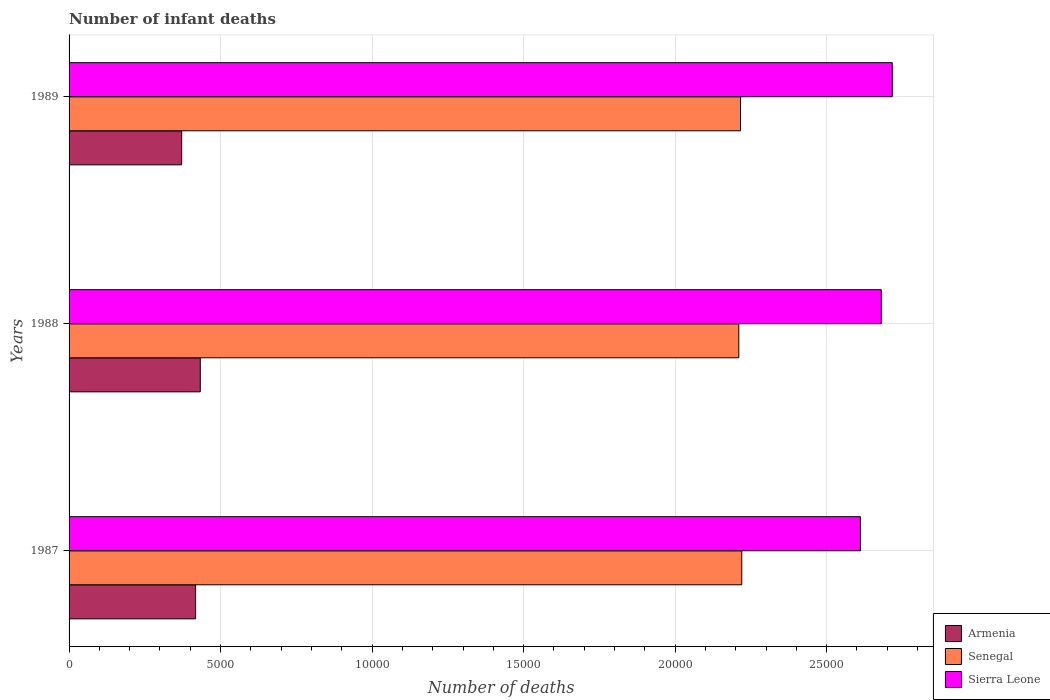How many groups of bars are there?
Your answer should be compact. 3. Are the number of bars per tick equal to the number of legend labels?
Offer a very short reply. Yes. What is the label of the 3rd group of bars from the top?
Provide a succinct answer. 1987. In how many cases, is the number of bars for a given year not equal to the number of legend labels?
Make the answer very short. 0. What is the number of infant deaths in Sierra Leone in 1987?
Ensure brevity in your answer.  2.61e+04. Across all years, what is the maximum number of infant deaths in Sierra Leone?
Provide a short and direct response. 2.72e+04. Across all years, what is the minimum number of infant deaths in Senegal?
Your response must be concise. 2.21e+04. What is the total number of infant deaths in Sierra Leone in the graph?
Your answer should be compact. 8.01e+04. What is the difference between the number of infant deaths in Sierra Leone in 1988 and that in 1989?
Keep it short and to the point. -363. What is the difference between the number of infant deaths in Senegal in 1987 and the number of infant deaths in Armenia in 1989?
Your answer should be very brief. 1.85e+04. What is the average number of infant deaths in Senegal per year?
Give a very brief answer. 2.22e+04. In the year 1989, what is the difference between the number of infant deaths in Sierra Leone and number of infant deaths in Armenia?
Your answer should be compact. 2.34e+04. In how many years, is the number of infant deaths in Sierra Leone greater than 15000 ?
Your answer should be compact. 3. What is the ratio of the number of infant deaths in Armenia in 1987 to that in 1989?
Ensure brevity in your answer.  1.12. Is the number of infant deaths in Sierra Leone in 1988 less than that in 1989?
Ensure brevity in your answer.  Yes. Is the difference between the number of infant deaths in Sierra Leone in 1987 and 1988 greater than the difference between the number of infant deaths in Armenia in 1987 and 1988?
Give a very brief answer. No. What is the difference between the highest and the second highest number of infant deaths in Armenia?
Your answer should be very brief. 155. What is the difference between the highest and the lowest number of infant deaths in Armenia?
Ensure brevity in your answer.  614. Is the sum of the number of infant deaths in Armenia in 1988 and 1989 greater than the maximum number of infant deaths in Senegal across all years?
Offer a terse response. No. What does the 3rd bar from the top in 1988 represents?
Your answer should be very brief. Armenia. What does the 2nd bar from the bottom in 1987 represents?
Provide a short and direct response. Senegal. Is it the case that in every year, the sum of the number of infant deaths in Sierra Leone and number of infant deaths in Senegal is greater than the number of infant deaths in Armenia?
Your answer should be very brief. Yes. How many years are there in the graph?
Provide a succinct answer. 3. Are the values on the major ticks of X-axis written in scientific E-notation?
Your answer should be compact. No. Where does the legend appear in the graph?
Ensure brevity in your answer.  Bottom right. How many legend labels are there?
Give a very brief answer. 3. How are the legend labels stacked?
Offer a terse response. Vertical. What is the title of the graph?
Give a very brief answer. Number of infant deaths. Does "Denmark" appear as one of the legend labels in the graph?
Keep it short and to the point. No. What is the label or title of the X-axis?
Provide a succinct answer. Number of deaths. What is the label or title of the Y-axis?
Make the answer very short. Years. What is the Number of deaths of Armenia in 1987?
Provide a short and direct response. 4175. What is the Number of deaths of Senegal in 1987?
Your answer should be very brief. 2.22e+04. What is the Number of deaths of Sierra Leone in 1987?
Provide a succinct answer. 2.61e+04. What is the Number of deaths of Armenia in 1988?
Give a very brief answer. 4330. What is the Number of deaths in Senegal in 1988?
Your answer should be very brief. 2.21e+04. What is the Number of deaths in Sierra Leone in 1988?
Your response must be concise. 2.68e+04. What is the Number of deaths in Armenia in 1989?
Ensure brevity in your answer.  3716. What is the Number of deaths of Senegal in 1989?
Give a very brief answer. 2.22e+04. What is the Number of deaths of Sierra Leone in 1989?
Give a very brief answer. 2.72e+04. Across all years, what is the maximum Number of deaths of Armenia?
Make the answer very short. 4330. Across all years, what is the maximum Number of deaths in Senegal?
Keep it short and to the point. 2.22e+04. Across all years, what is the maximum Number of deaths in Sierra Leone?
Offer a very short reply. 2.72e+04. Across all years, what is the minimum Number of deaths of Armenia?
Provide a succinct answer. 3716. Across all years, what is the minimum Number of deaths of Senegal?
Make the answer very short. 2.21e+04. Across all years, what is the minimum Number of deaths in Sierra Leone?
Your answer should be compact. 2.61e+04. What is the total Number of deaths of Armenia in the graph?
Offer a terse response. 1.22e+04. What is the total Number of deaths of Senegal in the graph?
Your answer should be compact. 6.65e+04. What is the total Number of deaths of Sierra Leone in the graph?
Give a very brief answer. 8.01e+04. What is the difference between the Number of deaths of Armenia in 1987 and that in 1988?
Keep it short and to the point. -155. What is the difference between the Number of deaths of Senegal in 1987 and that in 1988?
Keep it short and to the point. 97. What is the difference between the Number of deaths of Sierra Leone in 1987 and that in 1988?
Make the answer very short. -688. What is the difference between the Number of deaths in Armenia in 1987 and that in 1989?
Provide a short and direct response. 459. What is the difference between the Number of deaths in Senegal in 1987 and that in 1989?
Offer a very short reply. 41. What is the difference between the Number of deaths in Sierra Leone in 1987 and that in 1989?
Ensure brevity in your answer.  -1051. What is the difference between the Number of deaths in Armenia in 1988 and that in 1989?
Your answer should be very brief. 614. What is the difference between the Number of deaths in Senegal in 1988 and that in 1989?
Offer a terse response. -56. What is the difference between the Number of deaths of Sierra Leone in 1988 and that in 1989?
Make the answer very short. -363. What is the difference between the Number of deaths of Armenia in 1987 and the Number of deaths of Senegal in 1988?
Keep it short and to the point. -1.79e+04. What is the difference between the Number of deaths in Armenia in 1987 and the Number of deaths in Sierra Leone in 1988?
Make the answer very short. -2.26e+04. What is the difference between the Number of deaths of Senegal in 1987 and the Number of deaths of Sierra Leone in 1988?
Keep it short and to the point. -4604. What is the difference between the Number of deaths in Armenia in 1987 and the Number of deaths in Senegal in 1989?
Your answer should be compact. -1.80e+04. What is the difference between the Number of deaths in Armenia in 1987 and the Number of deaths in Sierra Leone in 1989?
Offer a very short reply. -2.30e+04. What is the difference between the Number of deaths in Senegal in 1987 and the Number of deaths in Sierra Leone in 1989?
Your answer should be compact. -4967. What is the difference between the Number of deaths of Armenia in 1988 and the Number of deaths of Senegal in 1989?
Offer a very short reply. -1.78e+04. What is the difference between the Number of deaths of Armenia in 1988 and the Number of deaths of Sierra Leone in 1989?
Make the answer very short. -2.28e+04. What is the difference between the Number of deaths in Senegal in 1988 and the Number of deaths in Sierra Leone in 1989?
Provide a succinct answer. -5064. What is the average Number of deaths in Armenia per year?
Make the answer very short. 4073.67. What is the average Number of deaths of Senegal per year?
Offer a terse response. 2.22e+04. What is the average Number of deaths of Sierra Leone per year?
Offer a terse response. 2.67e+04. In the year 1987, what is the difference between the Number of deaths in Armenia and Number of deaths in Senegal?
Make the answer very short. -1.80e+04. In the year 1987, what is the difference between the Number of deaths of Armenia and Number of deaths of Sierra Leone?
Your answer should be compact. -2.19e+04. In the year 1987, what is the difference between the Number of deaths in Senegal and Number of deaths in Sierra Leone?
Your answer should be compact. -3916. In the year 1988, what is the difference between the Number of deaths of Armenia and Number of deaths of Senegal?
Give a very brief answer. -1.78e+04. In the year 1988, what is the difference between the Number of deaths in Armenia and Number of deaths in Sierra Leone?
Keep it short and to the point. -2.25e+04. In the year 1988, what is the difference between the Number of deaths in Senegal and Number of deaths in Sierra Leone?
Offer a very short reply. -4701. In the year 1989, what is the difference between the Number of deaths of Armenia and Number of deaths of Senegal?
Make the answer very short. -1.84e+04. In the year 1989, what is the difference between the Number of deaths of Armenia and Number of deaths of Sierra Leone?
Keep it short and to the point. -2.34e+04. In the year 1989, what is the difference between the Number of deaths of Senegal and Number of deaths of Sierra Leone?
Your answer should be very brief. -5008. What is the ratio of the Number of deaths in Armenia in 1987 to that in 1988?
Your answer should be compact. 0.96. What is the ratio of the Number of deaths in Senegal in 1987 to that in 1988?
Provide a short and direct response. 1. What is the ratio of the Number of deaths of Sierra Leone in 1987 to that in 1988?
Give a very brief answer. 0.97. What is the ratio of the Number of deaths of Armenia in 1987 to that in 1989?
Keep it short and to the point. 1.12. What is the ratio of the Number of deaths of Sierra Leone in 1987 to that in 1989?
Ensure brevity in your answer.  0.96. What is the ratio of the Number of deaths of Armenia in 1988 to that in 1989?
Provide a succinct answer. 1.17. What is the ratio of the Number of deaths in Senegal in 1988 to that in 1989?
Your response must be concise. 1. What is the ratio of the Number of deaths of Sierra Leone in 1988 to that in 1989?
Your answer should be very brief. 0.99. What is the difference between the highest and the second highest Number of deaths of Armenia?
Provide a succinct answer. 155. What is the difference between the highest and the second highest Number of deaths of Sierra Leone?
Provide a short and direct response. 363. What is the difference between the highest and the lowest Number of deaths in Armenia?
Offer a terse response. 614. What is the difference between the highest and the lowest Number of deaths of Senegal?
Your response must be concise. 97. What is the difference between the highest and the lowest Number of deaths in Sierra Leone?
Offer a terse response. 1051. 